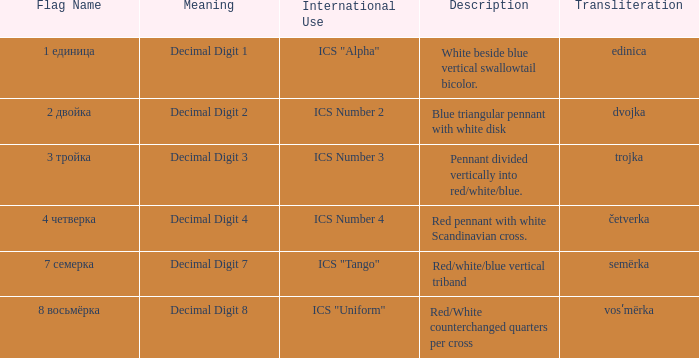What is the international use of the 1 единица flag? ICS "Alpha". 